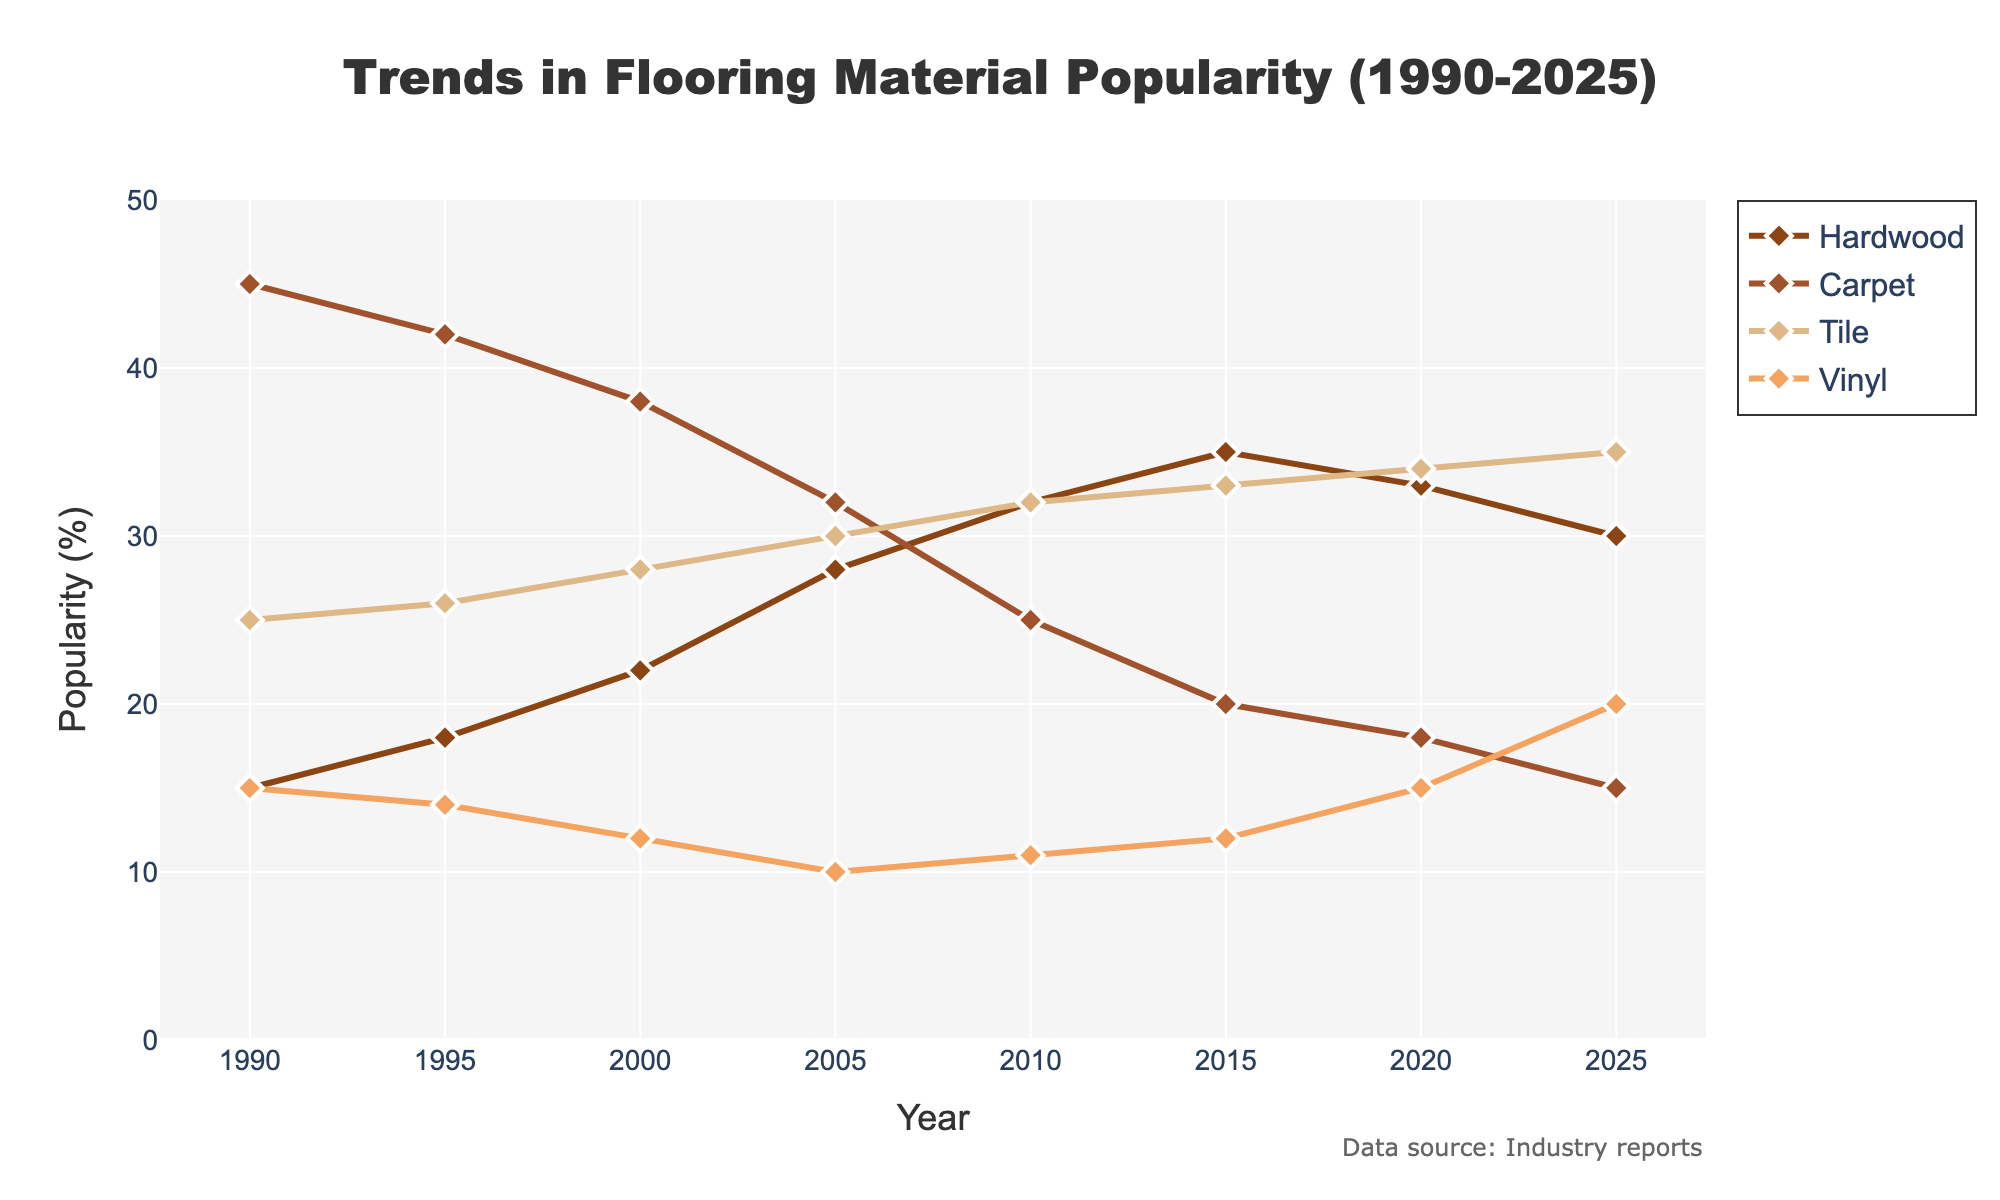What has been the trend in popularity for carpet flooring from 1990 to 2025? To observe the trend for carpet, we look at its popularity percentages over the years: 45 (1990), 42 (1995), 38 (2000), 32 (2005), 25 (2010), 20 (2015), 18 (2020), 15 (2025). The overall trend is clearly downward.
Answer: Downward In which year did tile flooring surpass hardwood flooring in popularity? We compare the popularity percentages year by year. In 2005, tile (30%) surpassed hardwood (28%) for the first time, and this trend continued onward.
Answer: 2005 How much did the popularity of vinyl flooring change from 1990 to 2025? To determine the change, calculate the difference between the values in 1990 (15%) and 2025 (20%): 20 - 15 = 5.
Answer: 5% Which year shows the highest popularity for hardwood flooring? We examine the popularity percentages for hardwood over the years: 15 (1990), 18 (1995), 22 (2000), 28 (2005), 32 (2010), 35 (2015), 33 (2020), 30 (2025). The highest value, 35%, occurs in 2015.
Answer: 2015 From 1990 to 2025, which flooring material saw the most significant overall increase in popularity? We compare the changes in popularity for each material: Hardwood increased from 15% to 30% (+15%), Carpet decreased from 45% to 15% (-30%), Tile increased from 25% to 35% (+10%), Vinyl increased from 15% to 20% (+5%). Hardwood shows the most significant increase.
Answer: Hardwood Which flooring material had the lowest popularity in 2025? We observe the popularity percentages in 2025: Hardwood (30%), Carpet (15%), Tile (35%), Vinyl (20%). The lowest percentage is for Carpet (15%).
Answer: Carpet What is the average popularity of tile flooring from 1990 to 2025? To calculate the average, sum the percentages and divide by the number of years: (25 + 26 + 28 + 30 + 32 + 33 + 34 + 35) / 8 = 243 / 8 = 30.375.
Answer: 30.375% How did the popularity of hardwood flooring change between 1990 and 2000? To find the change, calculate the difference between 2000 (22%) and 1990 (15%): 22 - 15 = 7.
Answer: 7% What was the general trend for vinyl flooring from 2005 to 2025? We look at the values: 10% (2005), 11% (2010), 12% (2015), 15% (2020), 20% (2025). The overall trend is upward.
Answer: Upward 